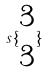<formula> <loc_0><loc_0><loc_500><loc_500>s \{ \begin{matrix} 3 \\ 3 \end{matrix} \}</formula> 